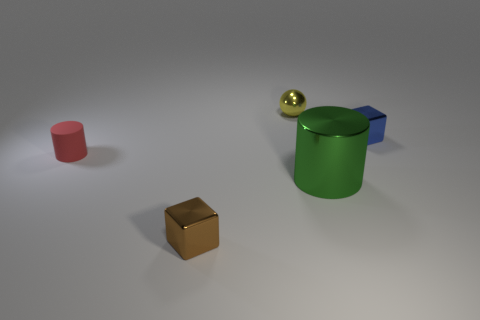The green metal object is what size?
Offer a terse response. Large. Does the cube to the right of the tiny sphere have the same material as the red object?
Make the answer very short. No. How many other objects are the same material as the big object?
Ensure brevity in your answer.  3. What number of objects are blocks behind the matte cylinder or tiny objects that are to the right of the yellow thing?
Provide a short and direct response. 1. Does the small blue thing that is to the right of the brown metallic object have the same shape as the small metallic object that is in front of the tiny matte object?
Offer a very short reply. Yes. There is a yellow thing that is the same size as the brown metal cube; what is its shape?
Ensure brevity in your answer.  Sphere. What number of metal things are small brown things or balls?
Your answer should be very brief. 2. Is the material of the cube right of the yellow ball the same as the cylinder that is on the right side of the matte object?
Your answer should be compact. Yes. What color is the large cylinder that is made of the same material as the tiny yellow ball?
Your answer should be very brief. Green. Are there more red matte objects that are in front of the brown metallic object than yellow spheres that are in front of the blue object?
Your answer should be very brief. No. 